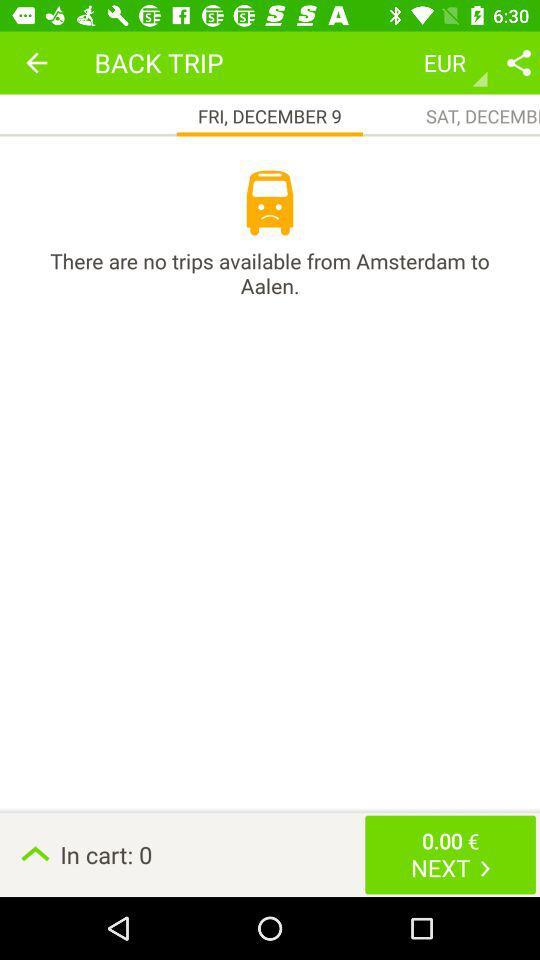What is the currency unit? The unit of currency is the "Euro". 